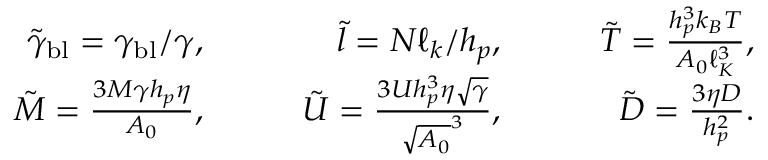<formula> <loc_0><loc_0><loc_500><loc_500>\begin{array} { r l r l r l r } & { \tilde { \gamma } _ { b l } = \gamma _ { b l } / \gamma , \quad } & { \tilde { l } = N \ell _ { k } / h _ { p } , \quad } & { \tilde { T } = \frac { h _ { p } ^ { 3 } k _ { B } T } { A _ { 0 } \ell _ { K } ^ { 3 } } , } \\ & { \tilde { M } = \frac { 3 M \gamma h _ { p } \eta } { A _ { 0 } } , \quad } & { \tilde { U } = \frac { 3 U h _ { p } ^ { 3 } \eta \sqrt { \gamma } } { \sqrt { A _ { 0 } } ^ { 3 } } , \quad } & { \tilde { D } = \frac { 3 \eta D } { h _ { p } ^ { 2 } } . } \end{array}</formula> 